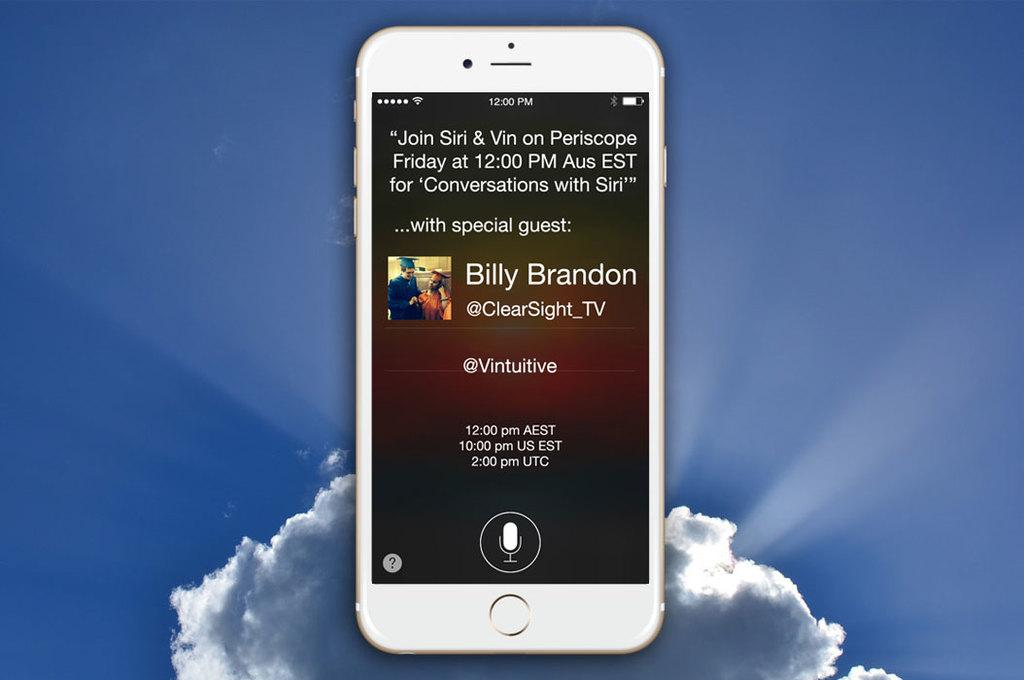<image>
Create a compact narrative representing the image presented. A cell phone is displaying a tweet by Billy Brandon. 